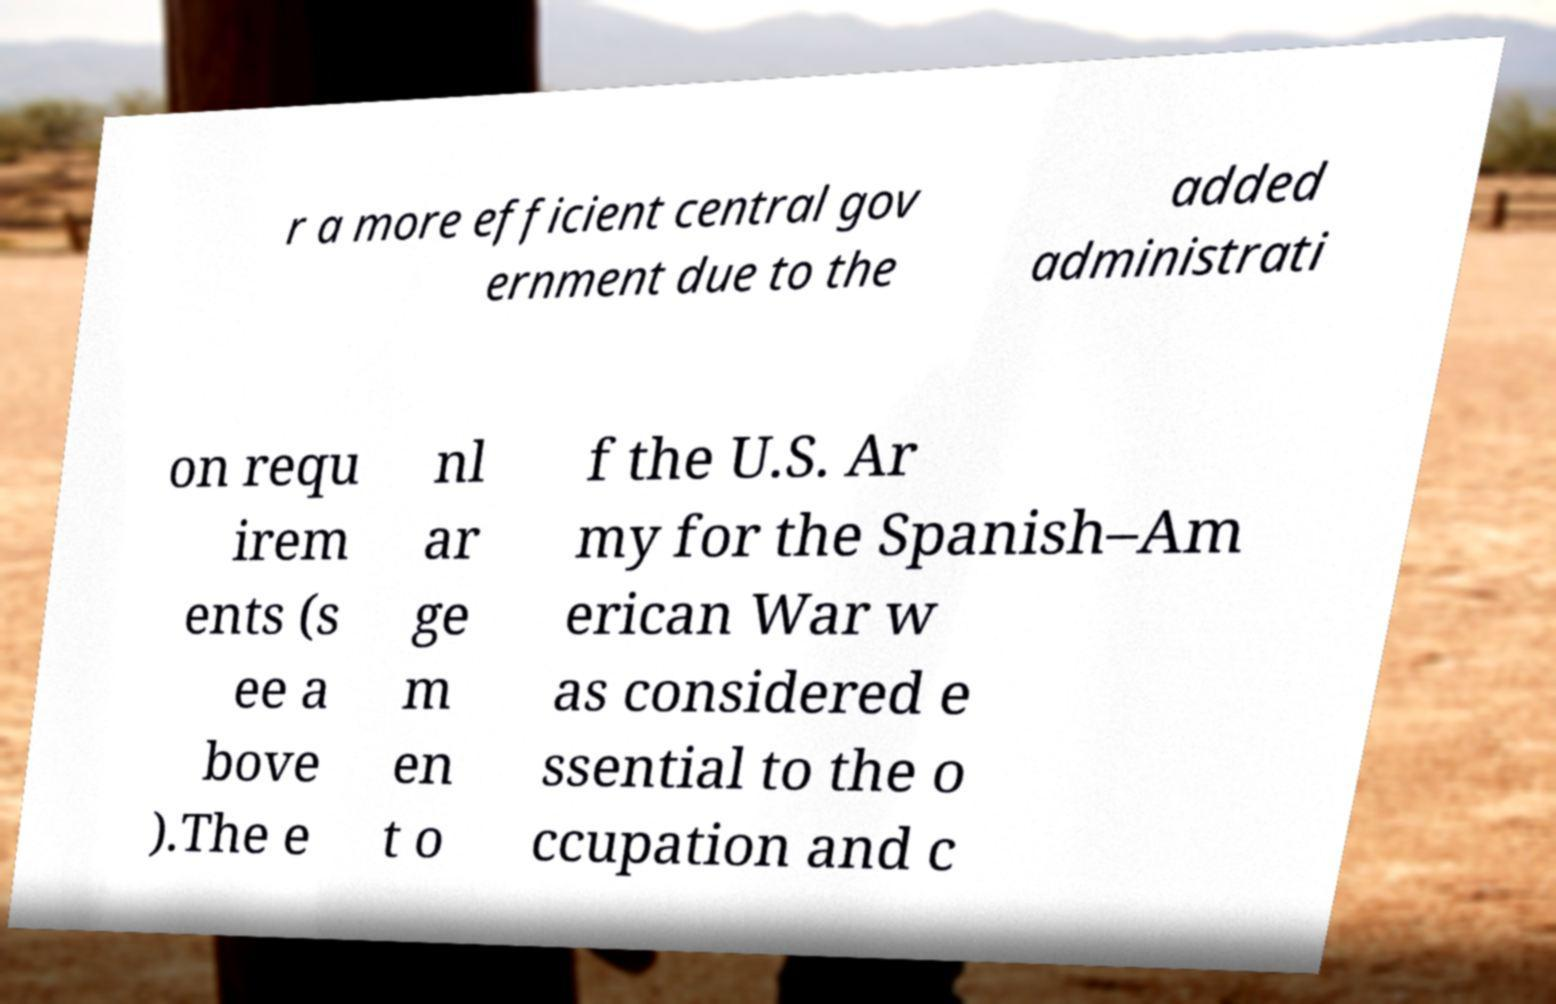There's text embedded in this image that I need extracted. Can you transcribe it verbatim? r a more efficient central gov ernment due to the added administrati on requ irem ents (s ee a bove ).The e nl ar ge m en t o f the U.S. Ar my for the Spanish–Am erican War w as considered e ssential to the o ccupation and c 